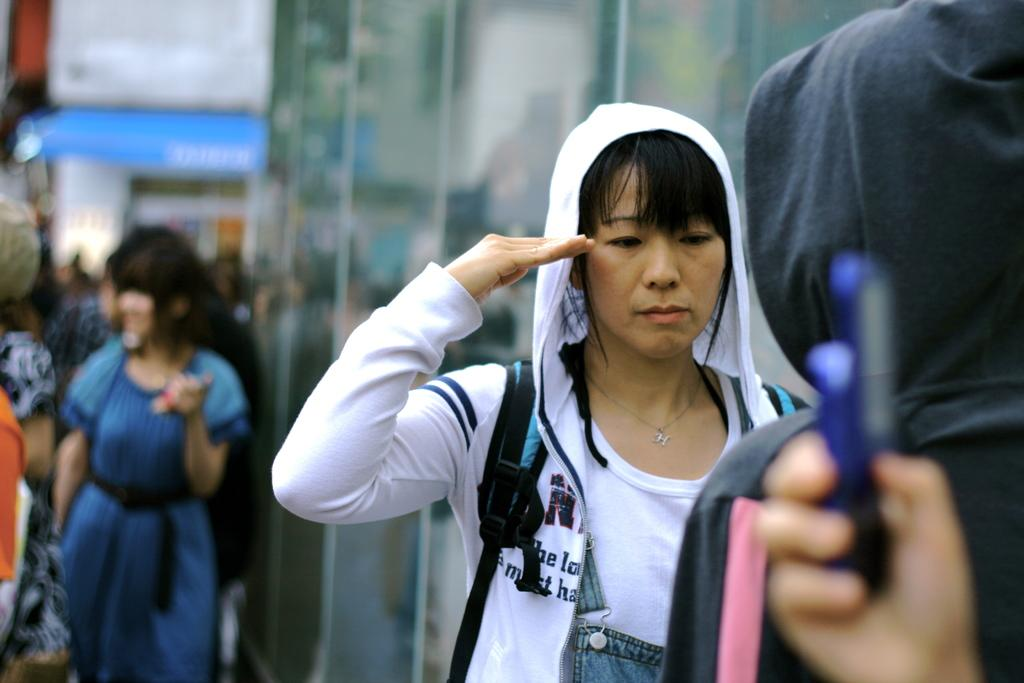How many people are in the image? There are many persons in the image. What are the persons in the image doing? The persons are walking on the ground. What can be seen in the background of the image? There is a wall in the background of the image. What degree of difficulty is the fly performing in the image? There is no fly present in the image, so it is not possible to determine the degree of difficulty of any fly-related activity. 